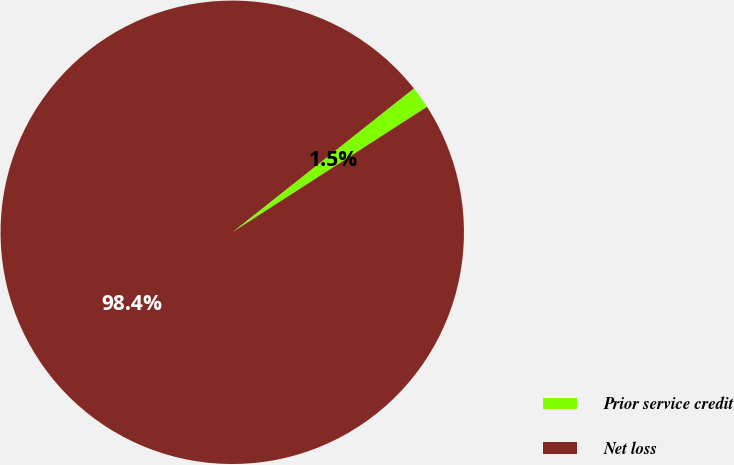Convert chart to OTSL. <chart><loc_0><loc_0><loc_500><loc_500><pie_chart><fcel>Prior service credit<fcel>Net loss<nl><fcel>1.55%<fcel>98.45%<nl></chart> 